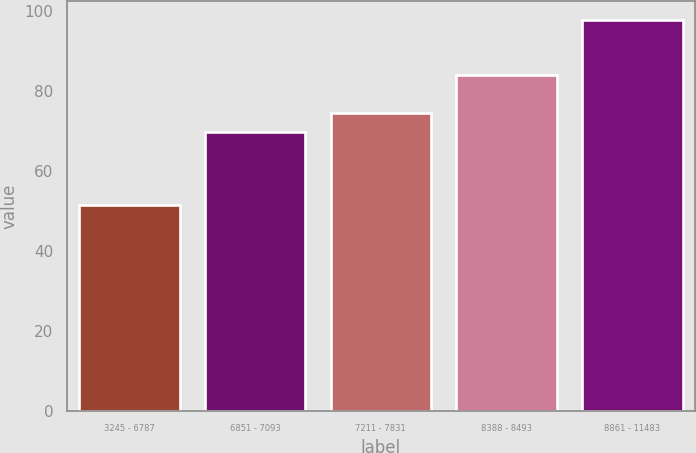Convert chart to OTSL. <chart><loc_0><loc_0><loc_500><loc_500><bar_chart><fcel>3245 - 6787<fcel>6851 - 7093<fcel>7211 - 7831<fcel>8388 - 8493<fcel>8861 - 11483<nl><fcel>51.5<fcel>69.82<fcel>74.45<fcel>84.17<fcel>97.78<nl></chart> 